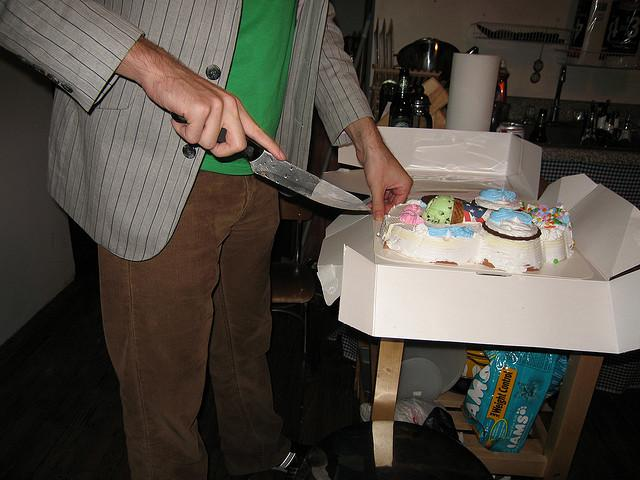What might be a major component of this treat? Please explain your reasoning. ice cream. The cake has an ice cream frosting. 